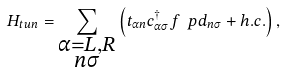Convert formula to latex. <formula><loc_0><loc_0><loc_500><loc_500>H _ { t u n } = \sum _ { \substack { \alpha = L , R \\ n \sigma } } \left ( t _ { \alpha n } c _ { \alpha \sigma } ^ { \dagger } f ^ { \ } p d _ { n \sigma } + h . c . \right ) ,</formula> 